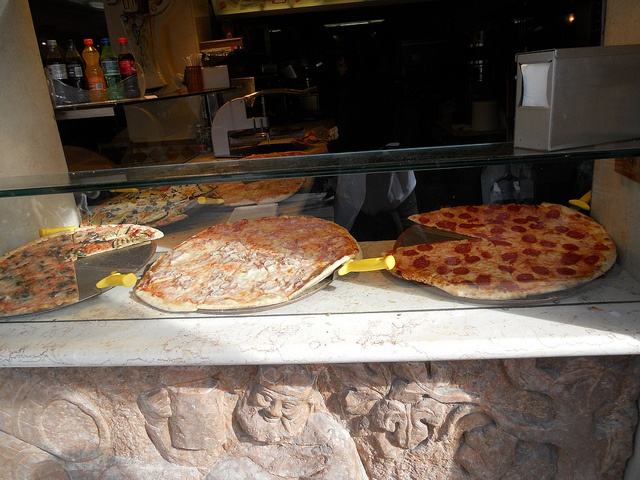Describe the objects in this image and their specific colors. I can see pizza in gray, maroon, brown, and black tones, pizza in gray, tan, brown, and beige tones, people in gray, black, and brown tones, pizza in gray, maroon, and brown tones, and pizza in gray, maroon, and brown tones in this image. 